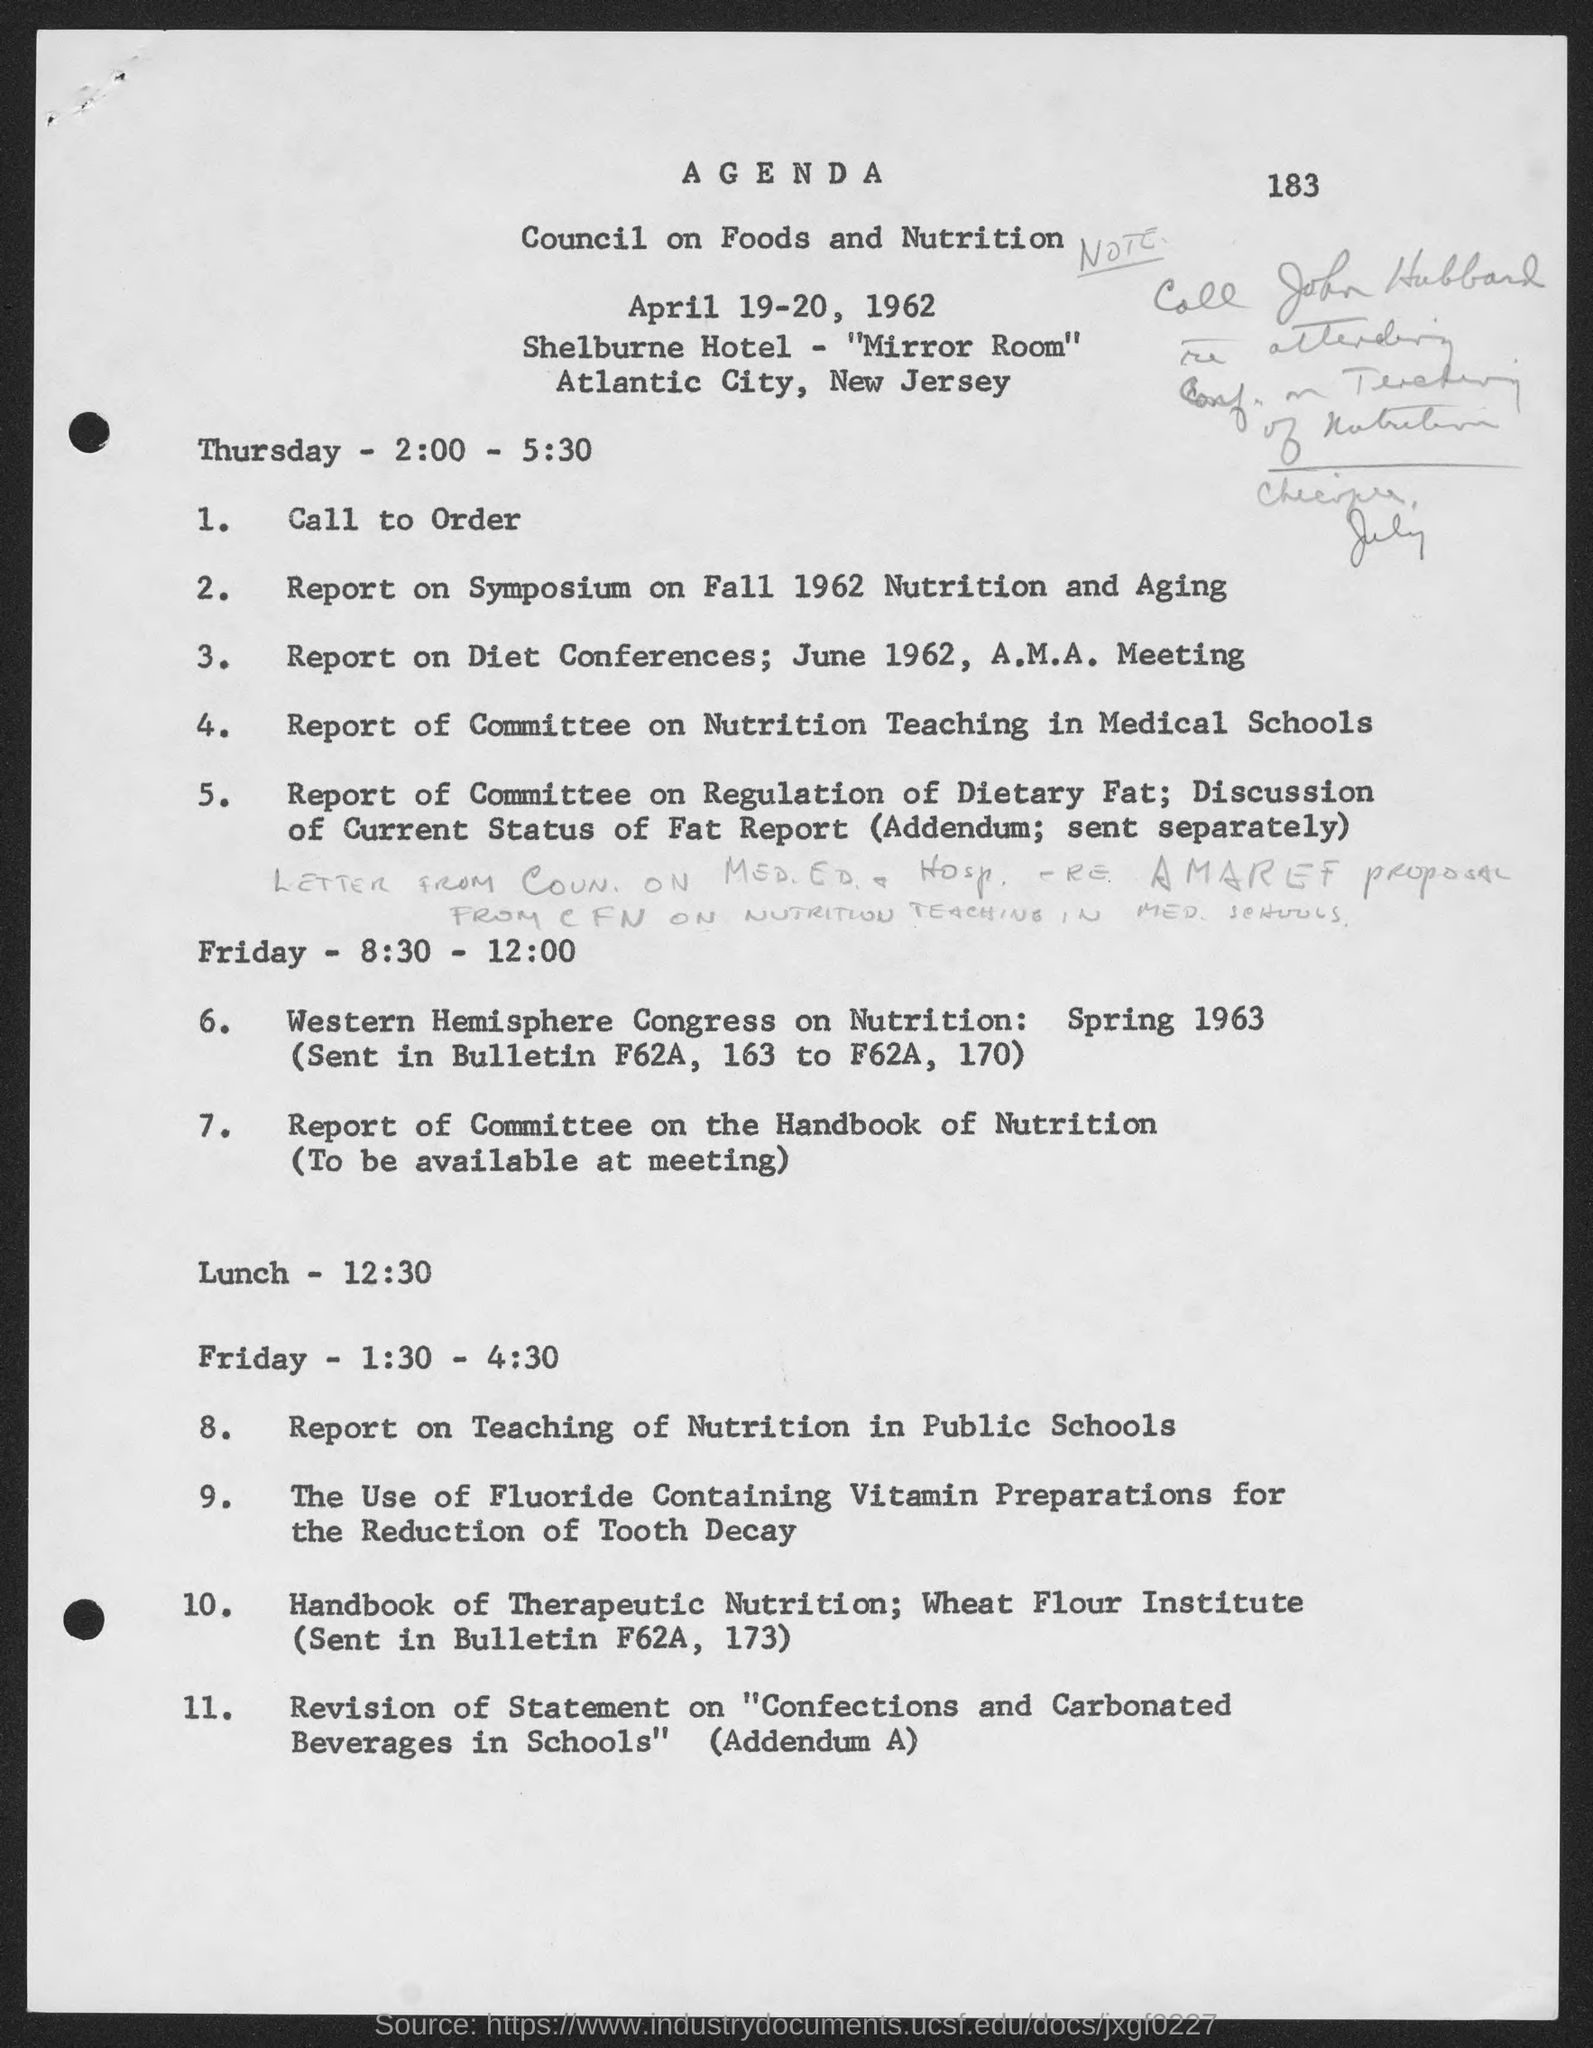When is the Council?
Provide a succinct answer. April 19-20, 1962. Where is it held?
Offer a terse response. Shelburne Hotel - "Mirror Room". Where is the location?
Your response must be concise. Atlantic City, New Jersey. When is the Lunch?
Ensure brevity in your answer.  12:30. 